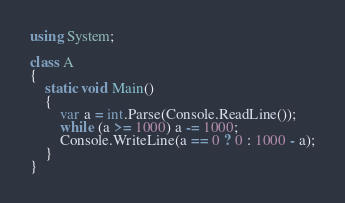Convert code to text. <code><loc_0><loc_0><loc_500><loc_500><_C#_>using System;

class A
{
	static void Main()
	{
		var a = int.Parse(Console.ReadLine());
		while (a >= 1000) a -= 1000;
		Console.WriteLine(a == 0 ? 0 : 1000 - a);
	}
}</code> 